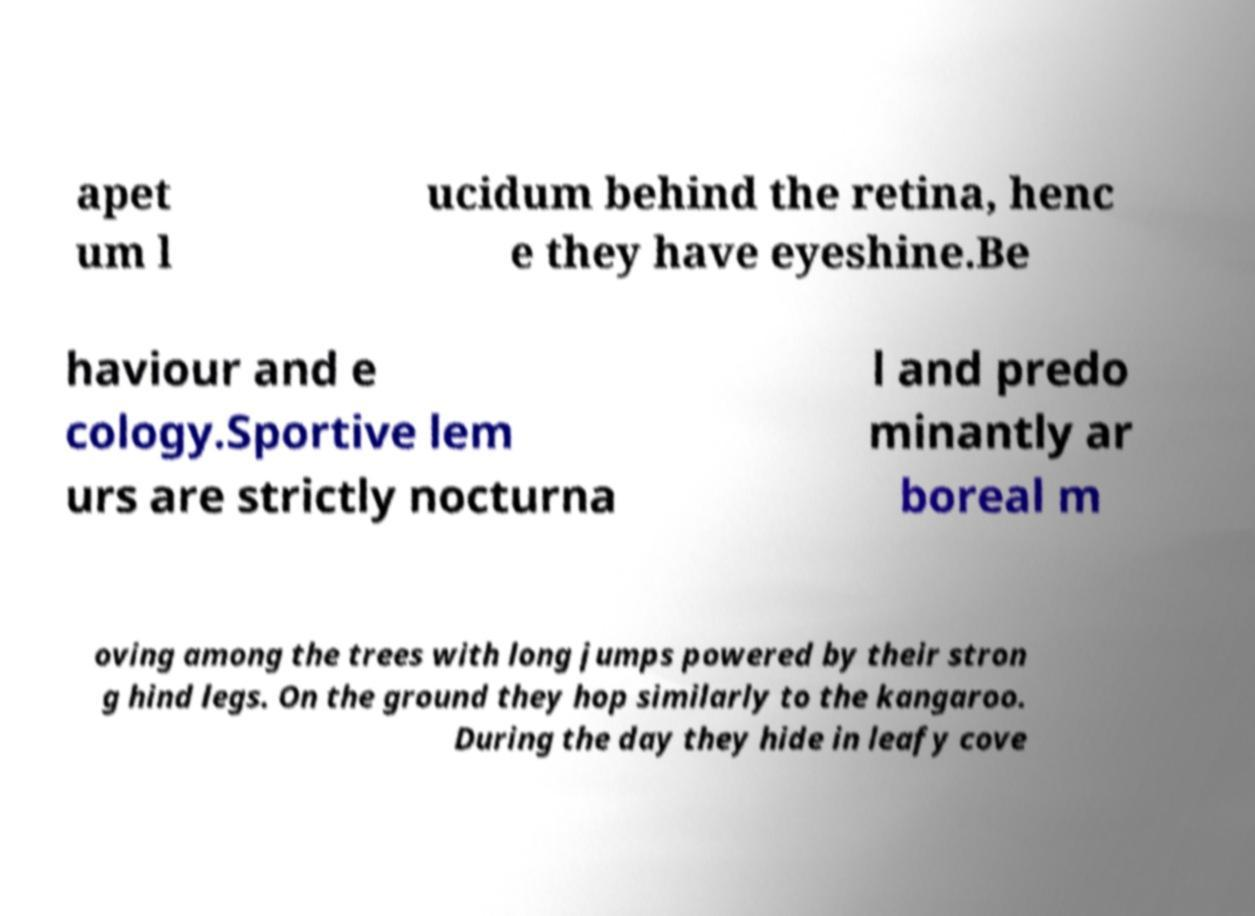Can you read and provide the text displayed in the image?This photo seems to have some interesting text. Can you extract and type it out for me? apet um l ucidum behind the retina, henc e they have eyeshine.Be haviour and e cology.Sportive lem urs are strictly nocturna l and predo minantly ar boreal m oving among the trees with long jumps powered by their stron g hind legs. On the ground they hop similarly to the kangaroo. During the day they hide in leafy cove 